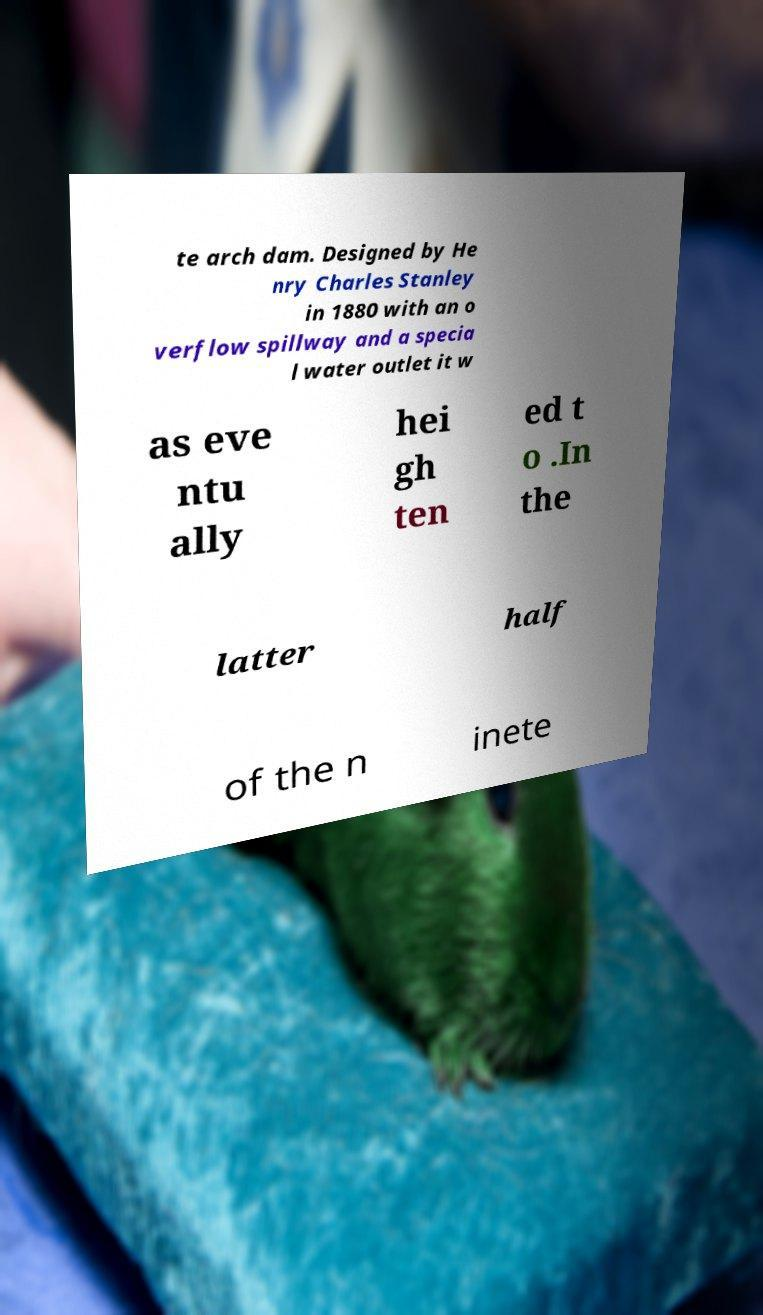Please read and relay the text visible in this image. What does it say? te arch dam. Designed by He nry Charles Stanley in 1880 with an o verflow spillway and a specia l water outlet it w as eve ntu ally hei gh ten ed t o .In the latter half of the n inete 